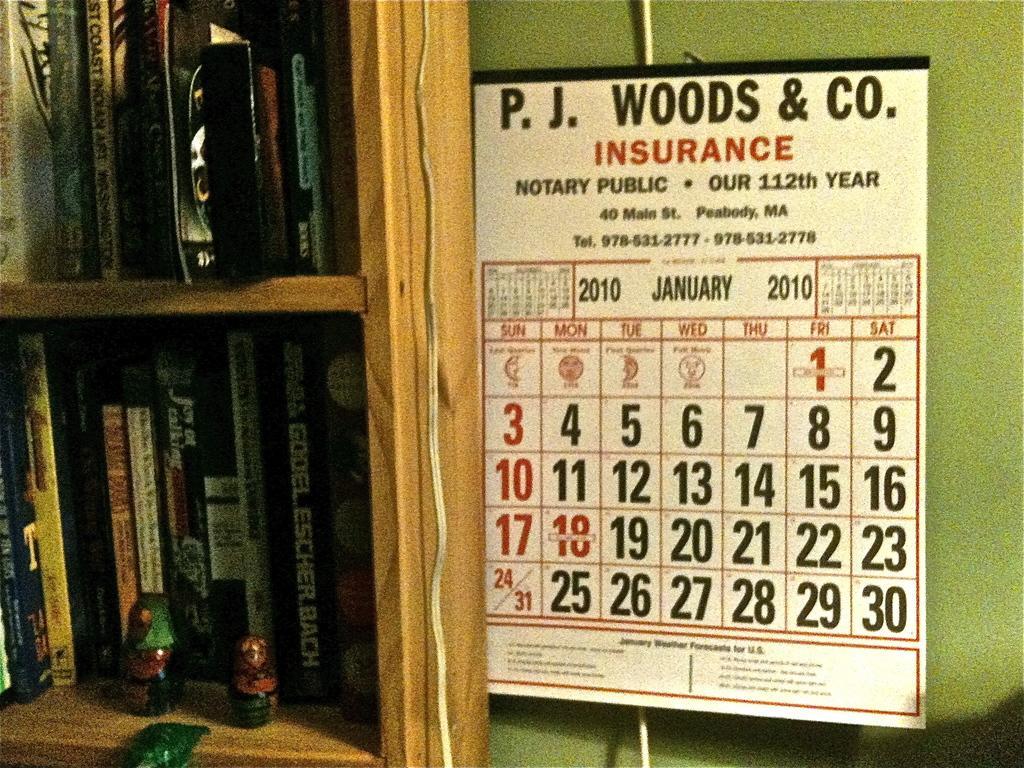How would you summarize this image in a sentence or two? Here we can see books and toys in racks and we can see calendar on green wall. 